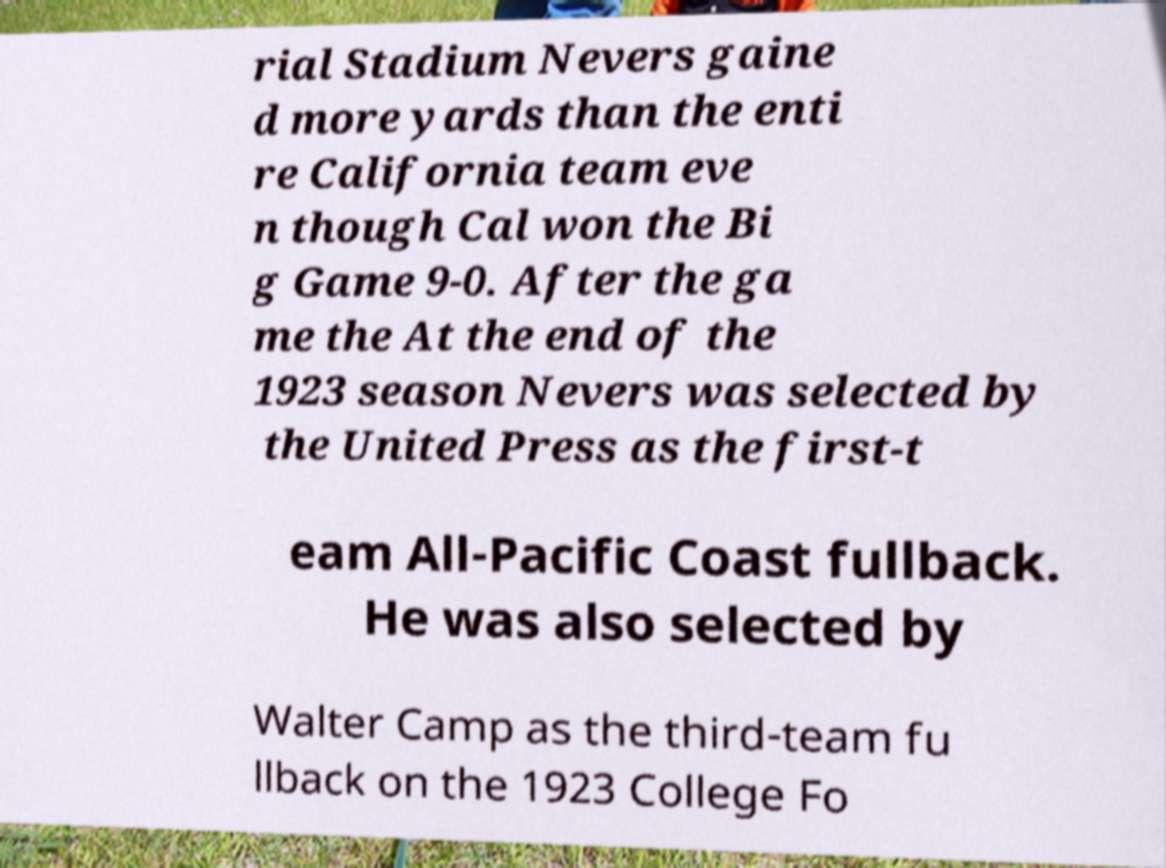Can you read and provide the text displayed in the image?This photo seems to have some interesting text. Can you extract and type it out for me? rial Stadium Nevers gaine d more yards than the enti re California team eve n though Cal won the Bi g Game 9-0. After the ga me the At the end of the 1923 season Nevers was selected by the United Press as the first-t eam All-Pacific Coast fullback. He was also selected by Walter Camp as the third-team fu llback on the 1923 College Fo 